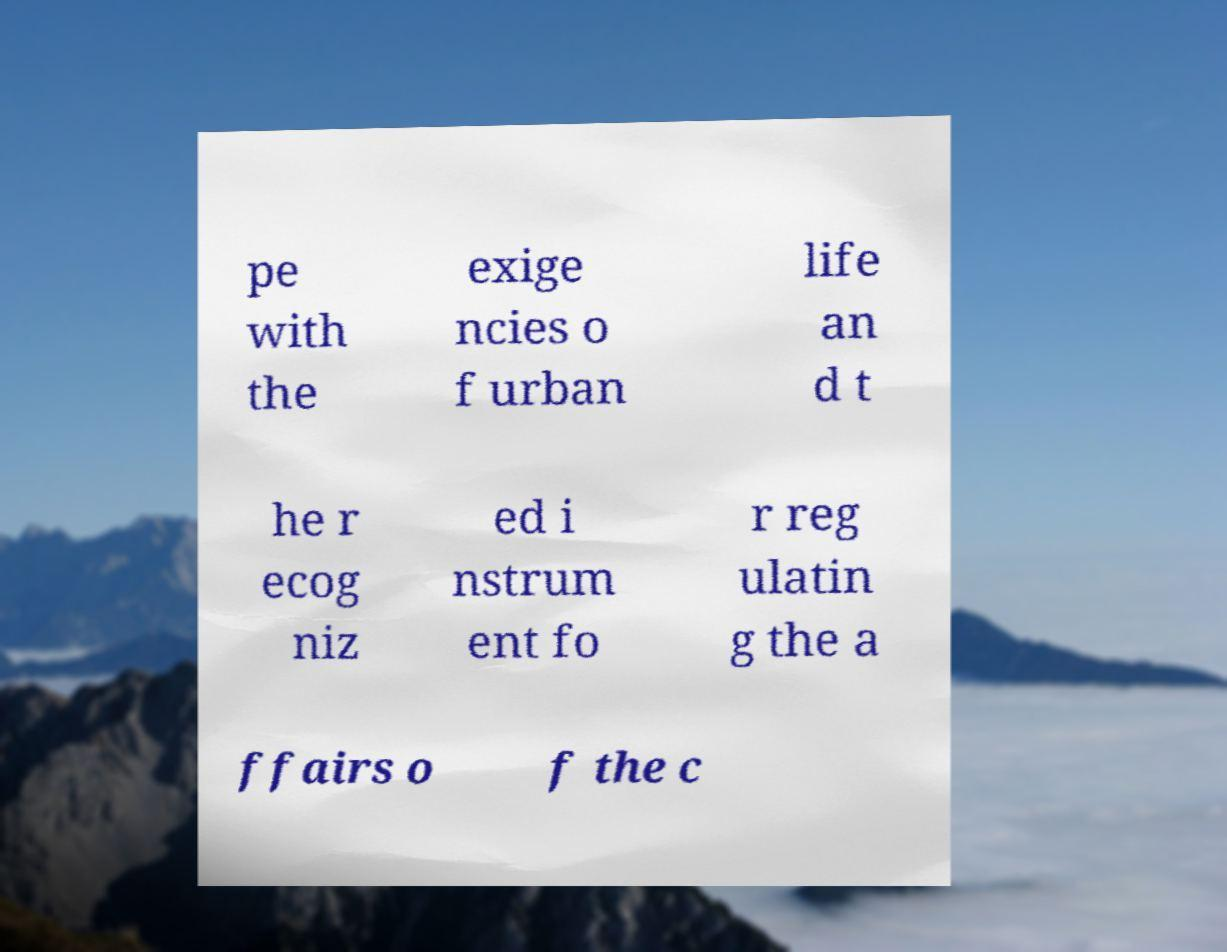For documentation purposes, I need the text within this image transcribed. Could you provide that? pe with the exige ncies o f urban life an d t he r ecog niz ed i nstrum ent fo r reg ulatin g the a ffairs o f the c 